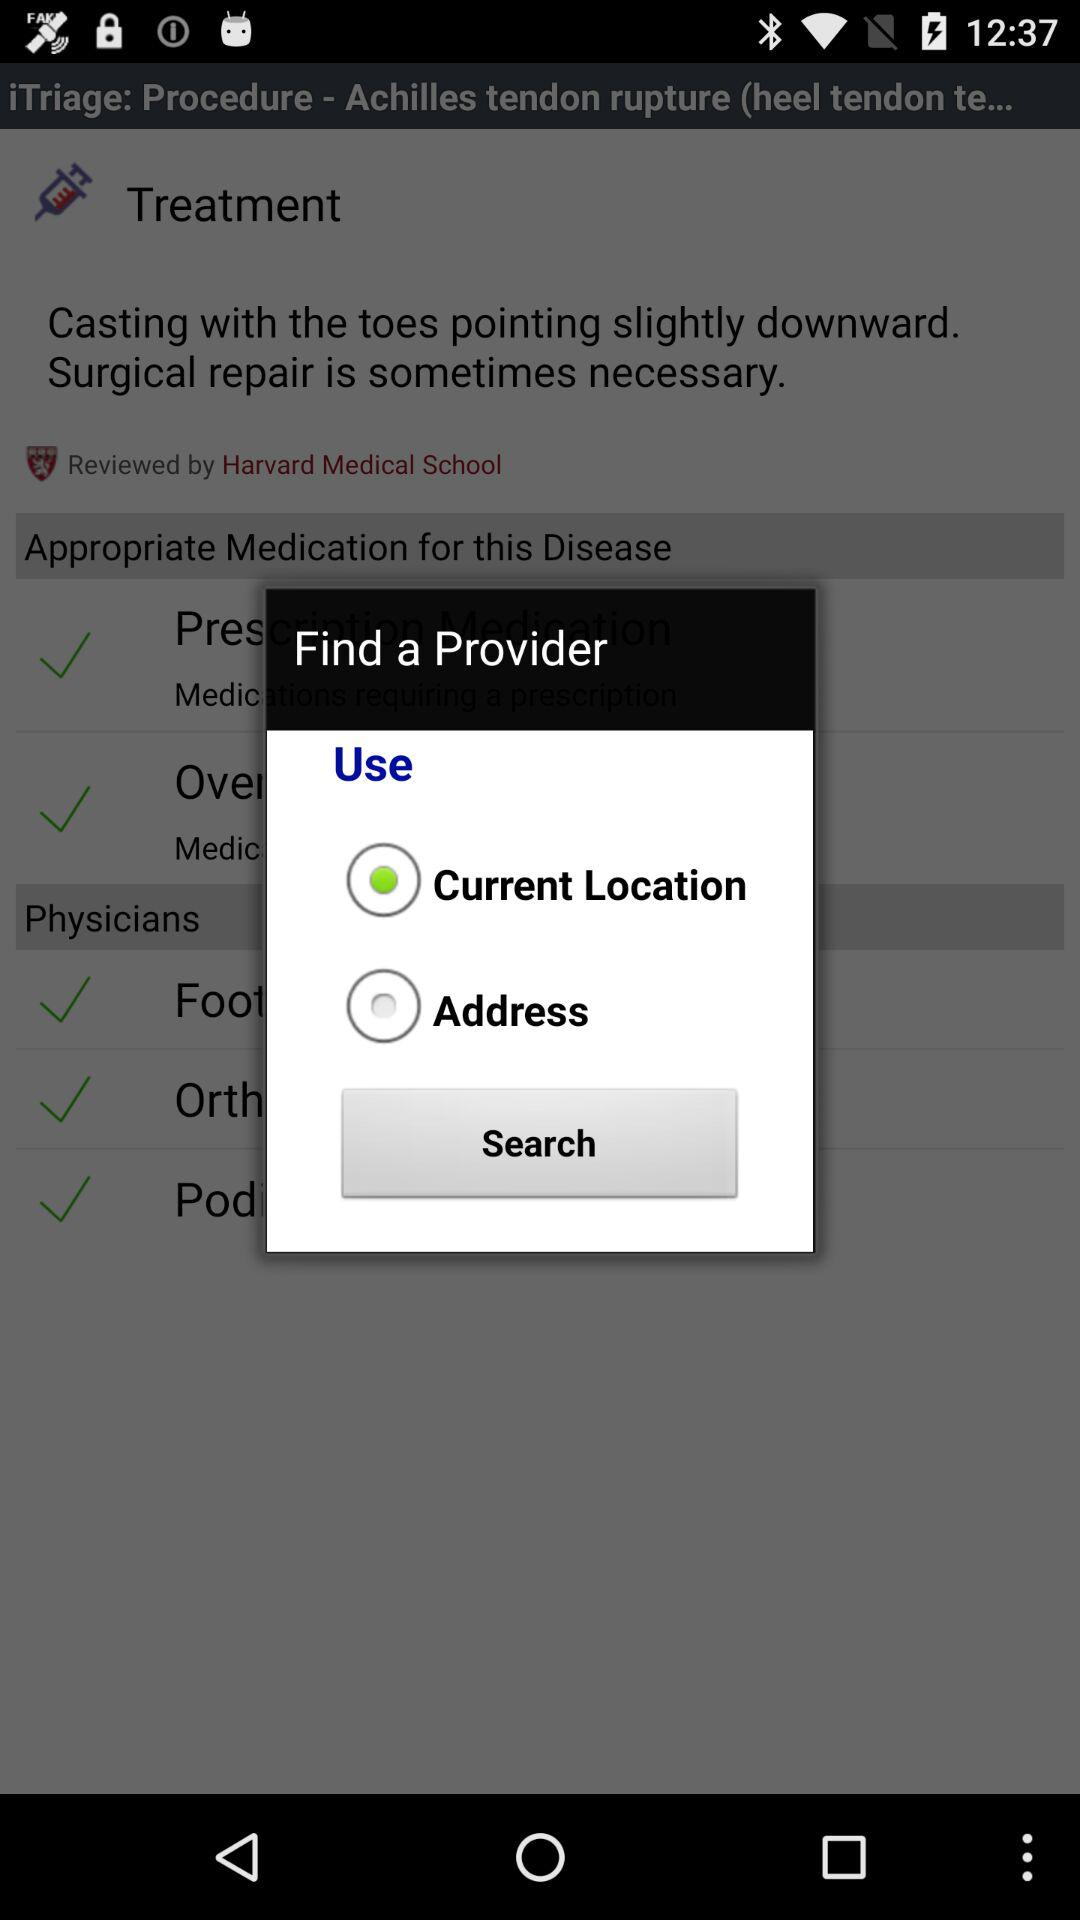Which provider was selected?
When the provided information is insufficient, respond with <no answer>. <no answer> 